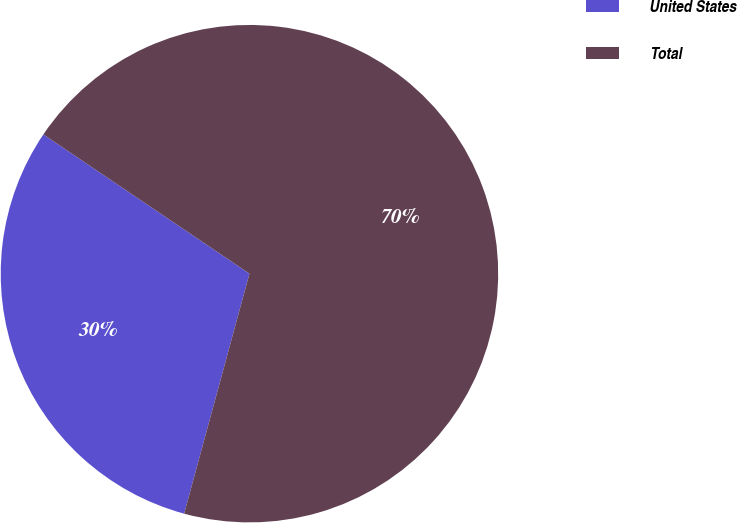<chart> <loc_0><loc_0><loc_500><loc_500><pie_chart><fcel>United States<fcel>Total<nl><fcel>30.23%<fcel>69.77%<nl></chart> 